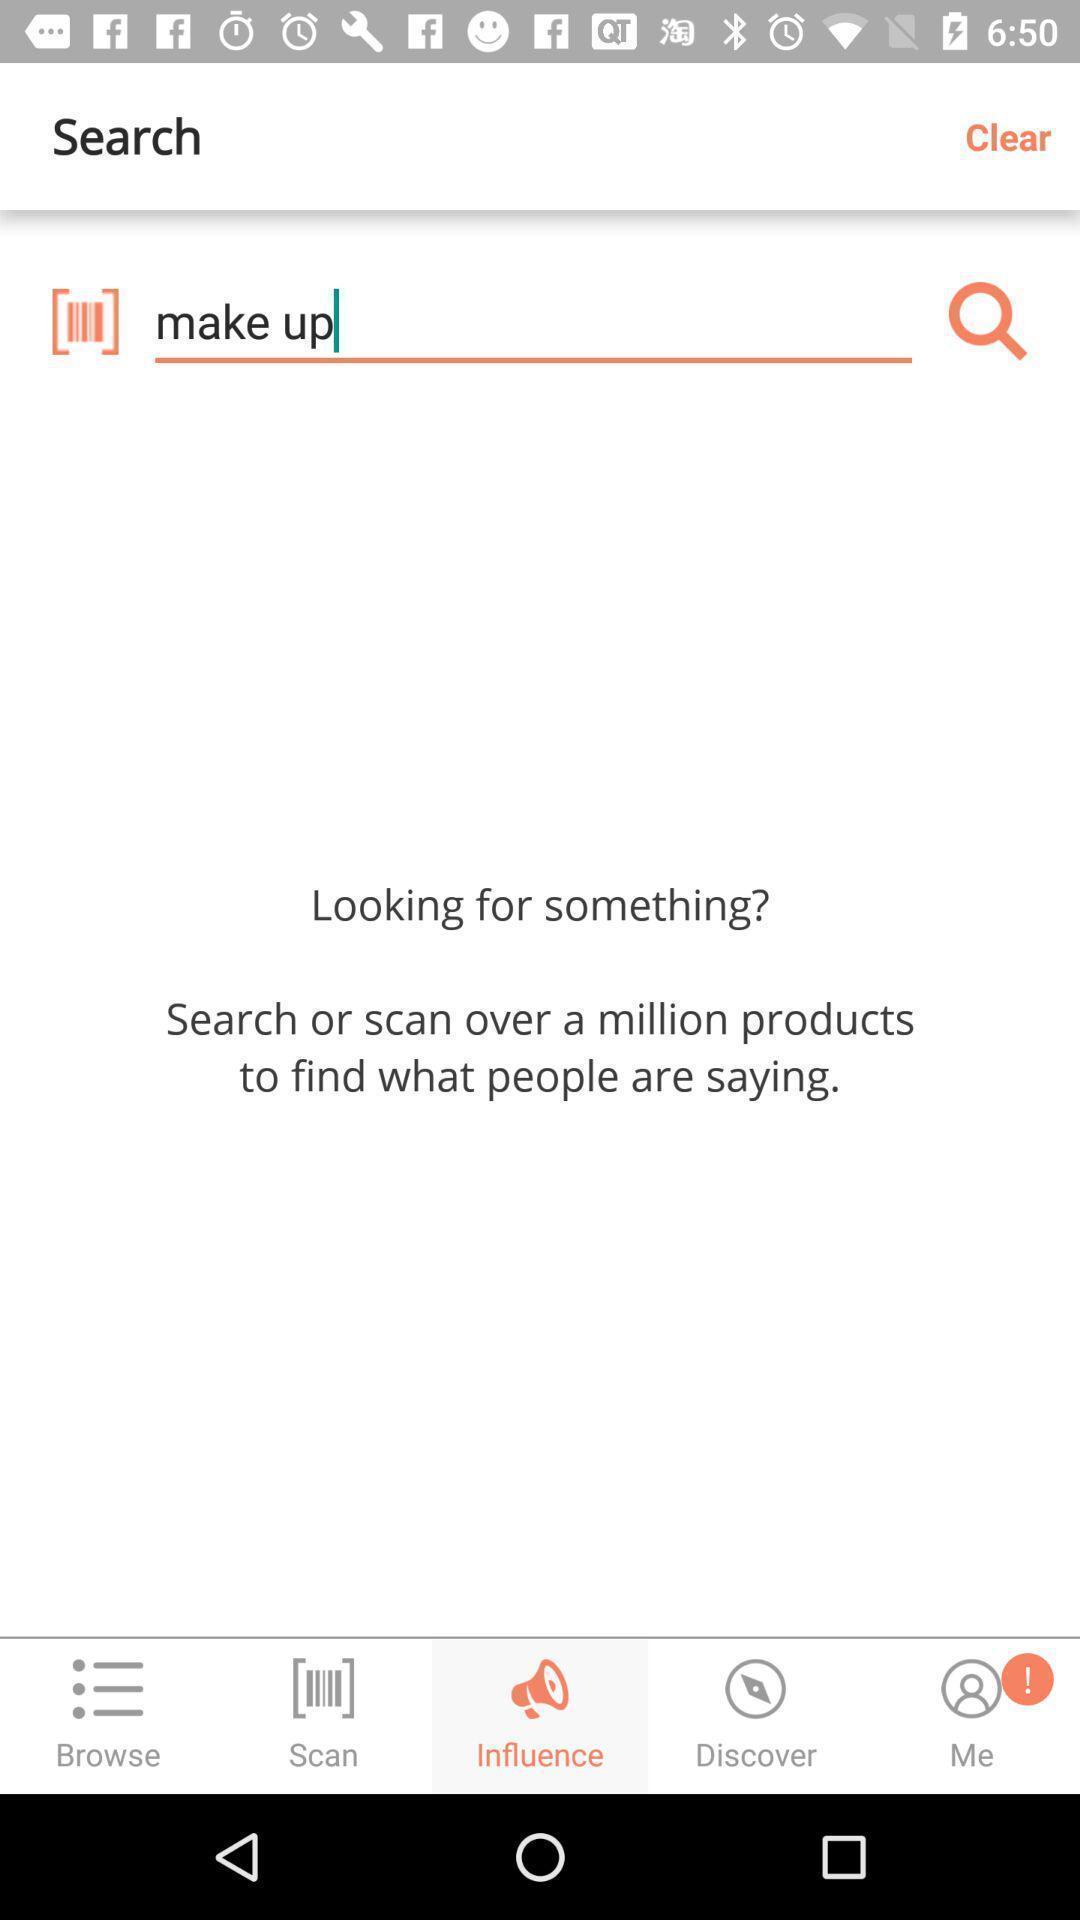Provide a detailed account of this screenshot. Search page for the shopping app. 